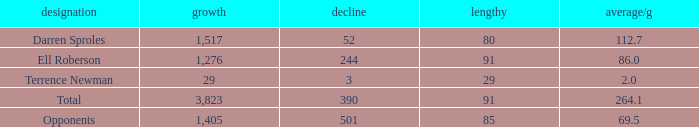When the Gain is 29, and the average per game is 2, and the player lost less than 390 yards, what's the sum of the Long yards? None. 